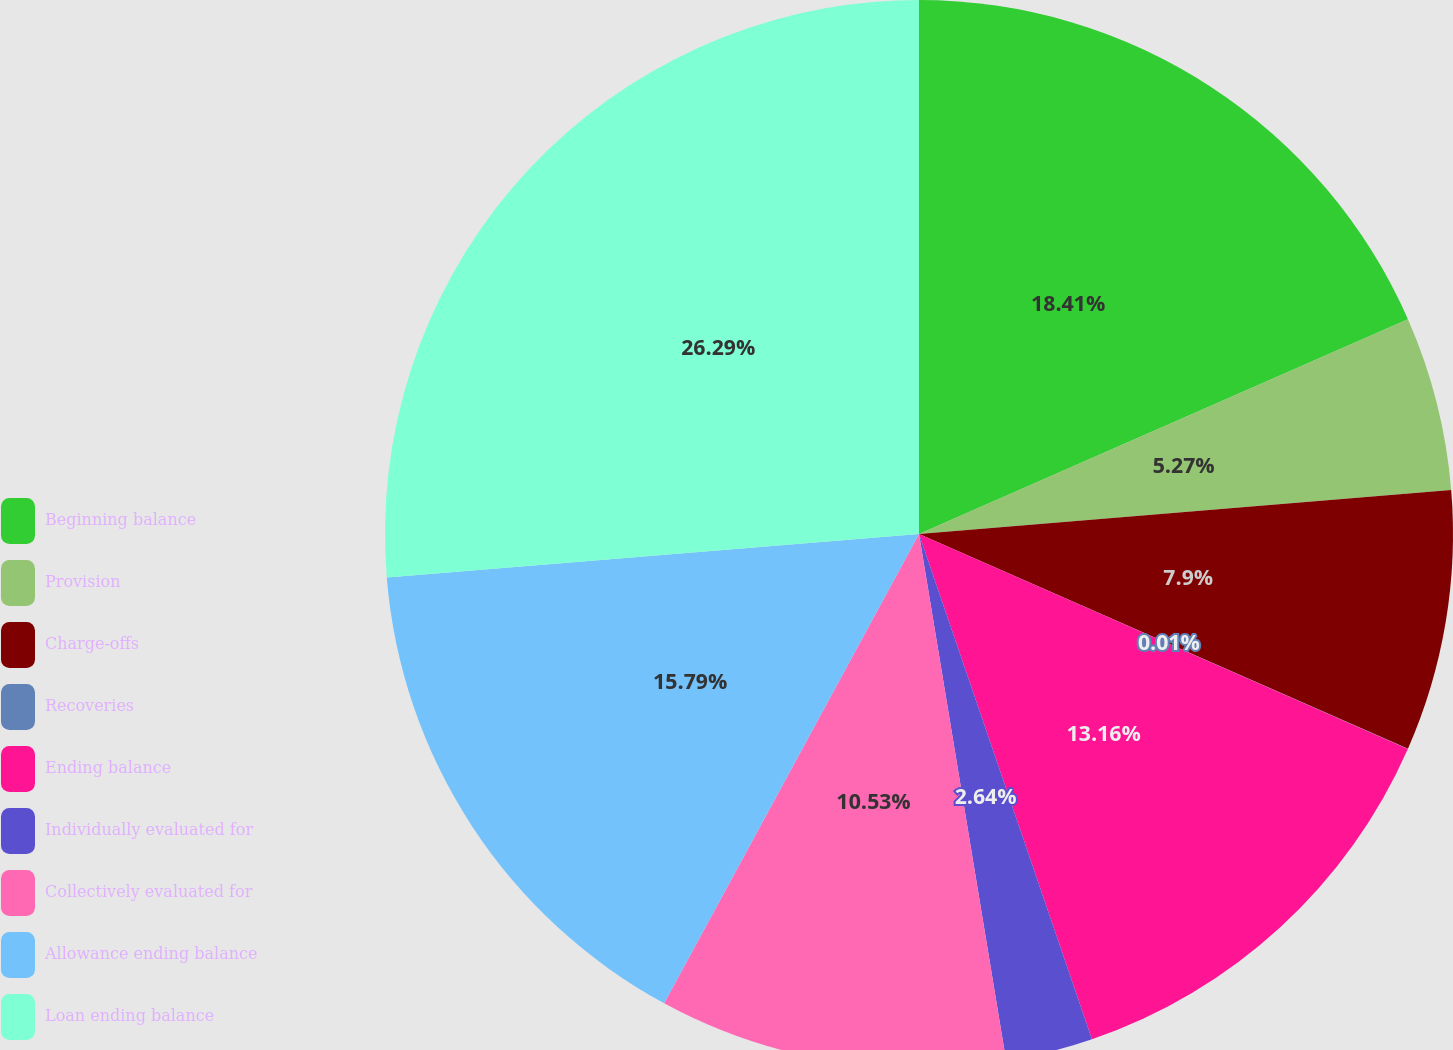Convert chart to OTSL. <chart><loc_0><loc_0><loc_500><loc_500><pie_chart><fcel>Beginning balance<fcel>Provision<fcel>Charge-offs<fcel>Recoveries<fcel>Ending balance<fcel>Individually evaluated for<fcel>Collectively evaluated for<fcel>Allowance ending balance<fcel>Loan ending balance<nl><fcel>18.42%<fcel>5.27%<fcel>7.9%<fcel>0.01%<fcel>13.16%<fcel>2.64%<fcel>10.53%<fcel>15.79%<fcel>26.3%<nl></chart> 